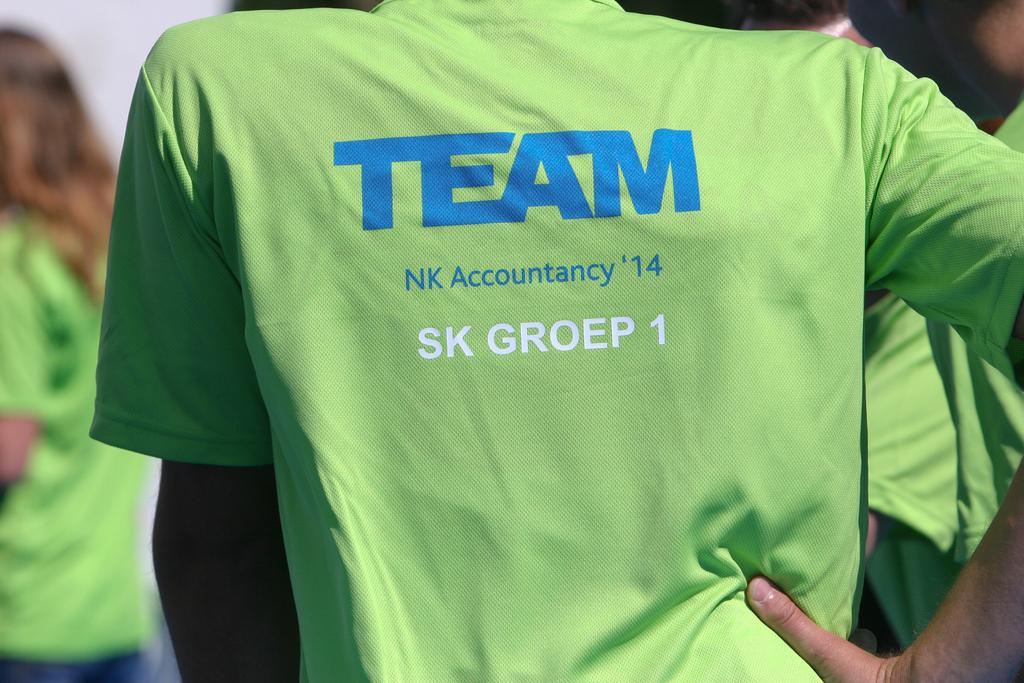<image>
Present a compact description of the photo's key features. A member of group 1 stands with their hand on their hip. 